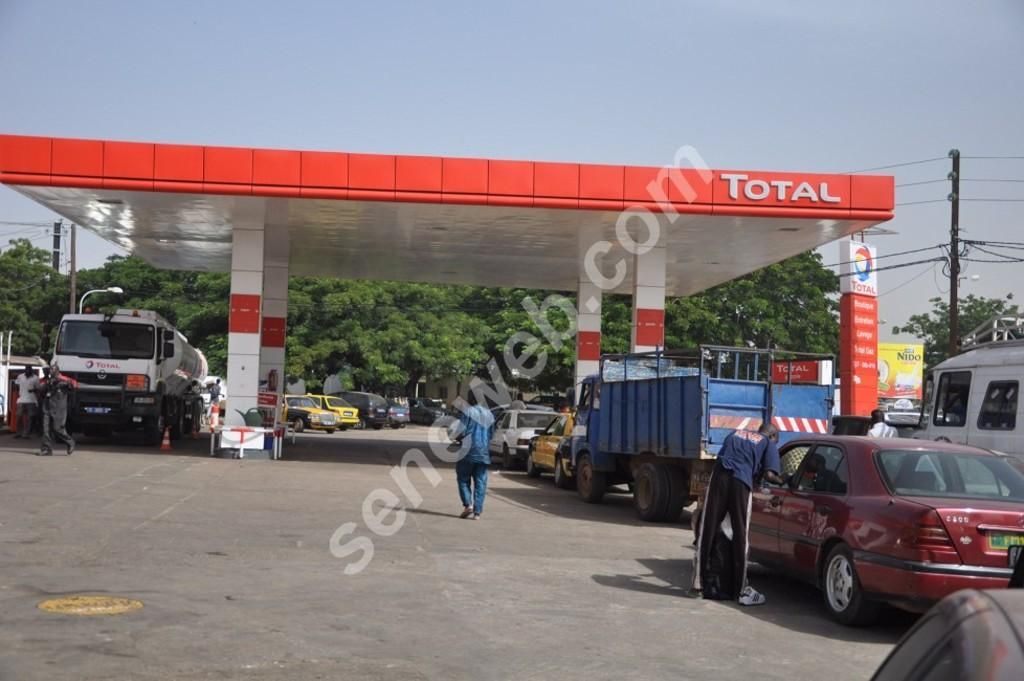<image>
Provide a brief description of the given image. Vehicles are filling up with gas at the Total gas station. 